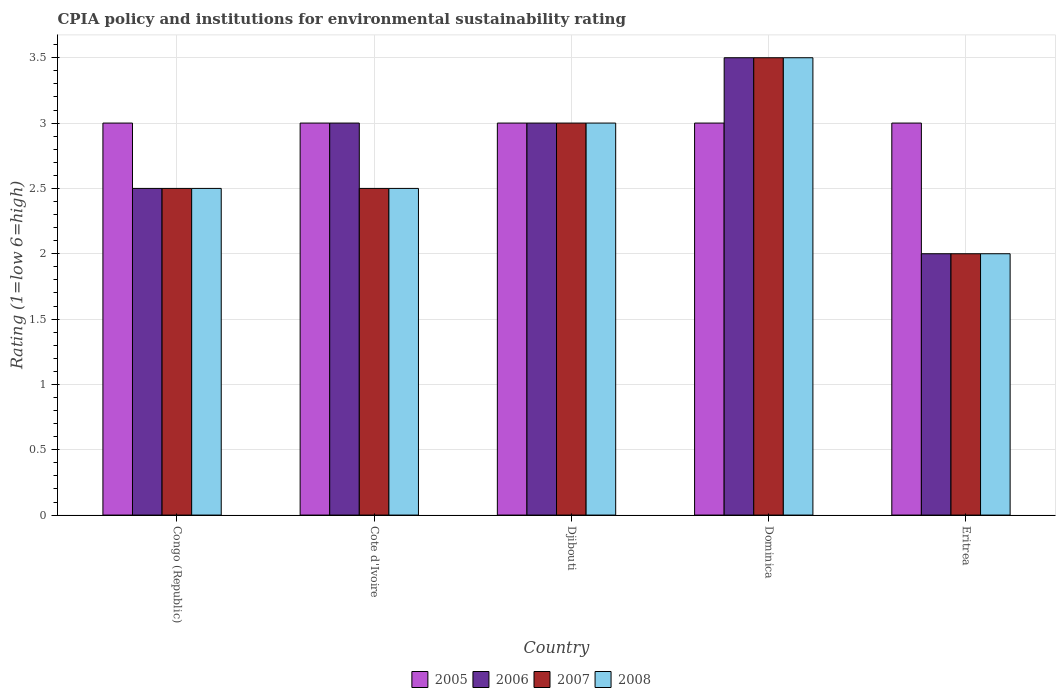Are the number of bars on each tick of the X-axis equal?
Ensure brevity in your answer.  Yes. How many bars are there on the 5th tick from the right?
Keep it short and to the point. 4. What is the label of the 3rd group of bars from the left?
Make the answer very short. Djibouti. In how many cases, is the number of bars for a given country not equal to the number of legend labels?
Provide a succinct answer. 0. Across all countries, what is the maximum CPIA rating in 2008?
Keep it short and to the point. 3.5. Across all countries, what is the minimum CPIA rating in 2008?
Give a very brief answer. 2. In which country was the CPIA rating in 2008 maximum?
Your response must be concise. Dominica. In which country was the CPIA rating in 2008 minimum?
Provide a succinct answer. Eritrea. What is the difference between the CPIA rating in 2008 in Congo (Republic) and that in Djibouti?
Your response must be concise. -0.5. What is the difference between the CPIA rating in 2006 in Eritrea and the CPIA rating in 2007 in Djibouti?
Your answer should be very brief. -1. What is the average CPIA rating in 2008 per country?
Offer a terse response. 2.7. What is the difference between the CPIA rating of/in 2008 and CPIA rating of/in 2007 in Djibouti?
Your answer should be very brief. 0. In how many countries, is the CPIA rating in 2008 greater than 1.3?
Your answer should be very brief. 5. What is the ratio of the CPIA rating in 2006 in Congo (Republic) to that in Cote d'Ivoire?
Keep it short and to the point. 0.83. Is the CPIA rating in 2005 in Congo (Republic) less than that in Djibouti?
Your answer should be very brief. No. In how many countries, is the CPIA rating in 2007 greater than the average CPIA rating in 2007 taken over all countries?
Provide a succinct answer. 2. What does the 1st bar from the left in Dominica represents?
Keep it short and to the point. 2005. How many bars are there?
Offer a very short reply. 20. Are all the bars in the graph horizontal?
Give a very brief answer. No. How many countries are there in the graph?
Your answer should be very brief. 5. Are the values on the major ticks of Y-axis written in scientific E-notation?
Offer a very short reply. No. Does the graph contain any zero values?
Offer a terse response. No. Does the graph contain grids?
Offer a terse response. Yes. Where does the legend appear in the graph?
Keep it short and to the point. Bottom center. How many legend labels are there?
Provide a short and direct response. 4. How are the legend labels stacked?
Make the answer very short. Horizontal. What is the title of the graph?
Provide a short and direct response. CPIA policy and institutions for environmental sustainability rating. What is the label or title of the Y-axis?
Provide a succinct answer. Rating (1=low 6=high). What is the Rating (1=low 6=high) of 2005 in Congo (Republic)?
Your response must be concise. 3. What is the Rating (1=low 6=high) in 2008 in Congo (Republic)?
Provide a succinct answer. 2.5. What is the Rating (1=low 6=high) in 2005 in Cote d'Ivoire?
Your answer should be very brief. 3. What is the Rating (1=low 6=high) of 2006 in Cote d'Ivoire?
Provide a succinct answer. 3. What is the Rating (1=low 6=high) in 2007 in Cote d'Ivoire?
Ensure brevity in your answer.  2.5. What is the Rating (1=low 6=high) of 2008 in Djibouti?
Offer a terse response. 3. What is the Rating (1=low 6=high) in 2005 in Dominica?
Give a very brief answer. 3. What is the Rating (1=low 6=high) of 2008 in Dominica?
Your response must be concise. 3.5. What is the Rating (1=low 6=high) of 2005 in Eritrea?
Offer a very short reply. 3. What is the Rating (1=low 6=high) of 2006 in Eritrea?
Provide a succinct answer. 2. What is the Rating (1=low 6=high) in 2008 in Eritrea?
Provide a succinct answer. 2. Across all countries, what is the maximum Rating (1=low 6=high) in 2005?
Offer a very short reply. 3. Across all countries, what is the maximum Rating (1=low 6=high) in 2007?
Provide a short and direct response. 3.5. Across all countries, what is the minimum Rating (1=low 6=high) of 2006?
Your answer should be compact. 2. Across all countries, what is the minimum Rating (1=low 6=high) of 2007?
Offer a terse response. 2. What is the total Rating (1=low 6=high) of 2006 in the graph?
Ensure brevity in your answer.  14. What is the difference between the Rating (1=low 6=high) in 2006 in Congo (Republic) and that in Cote d'Ivoire?
Offer a very short reply. -0.5. What is the difference between the Rating (1=low 6=high) in 2007 in Congo (Republic) and that in Cote d'Ivoire?
Your answer should be very brief. 0. What is the difference between the Rating (1=low 6=high) in 2006 in Congo (Republic) and that in Djibouti?
Give a very brief answer. -0.5. What is the difference between the Rating (1=low 6=high) in 2008 in Congo (Republic) and that in Djibouti?
Ensure brevity in your answer.  -0.5. What is the difference between the Rating (1=low 6=high) of 2005 in Congo (Republic) and that in Dominica?
Offer a very short reply. 0. What is the difference between the Rating (1=low 6=high) in 2008 in Congo (Republic) and that in Dominica?
Offer a very short reply. -1. What is the difference between the Rating (1=low 6=high) in 2005 in Congo (Republic) and that in Eritrea?
Make the answer very short. 0. What is the difference between the Rating (1=low 6=high) in 2006 in Congo (Republic) and that in Eritrea?
Provide a succinct answer. 0.5. What is the difference between the Rating (1=low 6=high) in 2007 in Congo (Republic) and that in Eritrea?
Provide a short and direct response. 0.5. What is the difference between the Rating (1=low 6=high) of 2007 in Cote d'Ivoire and that in Djibouti?
Make the answer very short. -0.5. What is the difference between the Rating (1=low 6=high) in 2005 in Cote d'Ivoire and that in Dominica?
Give a very brief answer. 0. What is the difference between the Rating (1=low 6=high) of 2005 in Cote d'Ivoire and that in Eritrea?
Ensure brevity in your answer.  0. What is the difference between the Rating (1=low 6=high) in 2005 in Djibouti and that in Dominica?
Your response must be concise. 0. What is the difference between the Rating (1=low 6=high) of 2008 in Djibouti and that in Dominica?
Your response must be concise. -0.5. What is the difference between the Rating (1=low 6=high) of 2005 in Djibouti and that in Eritrea?
Offer a very short reply. 0. What is the difference between the Rating (1=low 6=high) of 2007 in Djibouti and that in Eritrea?
Provide a succinct answer. 1. What is the difference between the Rating (1=low 6=high) of 2008 in Djibouti and that in Eritrea?
Ensure brevity in your answer.  1. What is the difference between the Rating (1=low 6=high) in 2005 in Dominica and that in Eritrea?
Your answer should be compact. 0. What is the difference between the Rating (1=low 6=high) of 2006 in Dominica and that in Eritrea?
Provide a succinct answer. 1.5. What is the difference between the Rating (1=low 6=high) of 2007 in Dominica and that in Eritrea?
Your answer should be compact. 1.5. What is the difference between the Rating (1=low 6=high) of 2005 in Congo (Republic) and the Rating (1=low 6=high) of 2007 in Cote d'Ivoire?
Give a very brief answer. 0.5. What is the difference between the Rating (1=low 6=high) in 2005 in Congo (Republic) and the Rating (1=low 6=high) in 2008 in Cote d'Ivoire?
Make the answer very short. 0.5. What is the difference between the Rating (1=low 6=high) of 2006 in Congo (Republic) and the Rating (1=low 6=high) of 2007 in Cote d'Ivoire?
Make the answer very short. 0. What is the difference between the Rating (1=low 6=high) in 2006 in Congo (Republic) and the Rating (1=low 6=high) in 2008 in Cote d'Ivoire?
Keep it short and to the point. 0. What is the difference between the Rating (1=low 6=high) in 2007 in Congo (Republic) and the Rating (1=low 6=high) in 2008 in Cote d'Ivoire?
Your answer should be compact. 0. What is the difference between the Rating (1=low 6=high) of 2005 in Congo (Republic) and the Rating (1=low 6=high) of 2006 in Djibouti?
Offer a very short reply. 0. What is the difference between the Rating (1=low 6=high) in 2005 in Congo (Republic) and the Rating (1=low 6=high) in 2008 in Djibouti?
Offer a very short reply. 0. What is the difference between the Rating (1=low 6=high) of 2006 in Congo (Republic) and the Rating (1=low 6=high) of 2007 in Djibouti?
Keep it short and to the point. -0.5. What is the difference between the Rating (1=low 6=high) of 2005 in Congo (Republic) and the Rating (1=low 6=high) of 2007 in Dominica?
Give a very brief answer. -0.5. What is the difference between the Rating (1=low 6=high) in 2005 in Congo (Republic) and the Rating (1=low 6=high) in 2008 in Dominica?
Your answer should be compact. -0.5. What is the difference between the Rating (1=low 6=high) of 2006 in Congo (Republic) and the Rating (1=low 6=high) of 2008 in Dominica?
Your answer should be compact. -1. What is the difference between the Rating (1=low 6=high) in 2005 in Congo (Republic) and the Rating (1=low 6=high) in 2008 in Eritrea?
Ensure brevity in your answer.  1. What is the difference between the Rating (1=low 6=high) of 2006 in Congo (Republic) and the Rating (1=low 6=high) of 2008 in Eritrea?
Provide a short and direct response. 0.5. What is the difference between the Rating (1=low 6=high) of 2007 in Congo (Republic) and the Rating (1=low 6=high) of 2008 in Eritrea?
Offer a terse response. 0.5. What is the difference between the Rating (1=low 6=high) of 2005 in Cote d'Ivoire and the Rating (1=low 6=high) of 2008 in Djibouti?
Your response must be concise. 0. What is the difference between the Rating (1=low 6=high) in 2007 in Cote d'Ivoire and the Rating (1=low 6=high) in 2008 in Djibouti?
Ensure brevity in your answer.  -0.5. What is the difference between the Rating (1=low 6=high) in 2005 in Cote d'Ivoire and the Rating (1=low 6=high) in 2006 in Dominica?
Your answer should be compact. -0.5. What is the difference between the Rating (1=low 6=high) of 2005 in Cote d'Ivoire and the Rating (1=low 6=high) of 2007 in Dominica?
Make the answer very short. -0.5. What is the difference between the Rating (1=low 6=high) of 2005 in Cote d'Ivoire and the Rating (1=low 6=high) of 2008 in Dominica?
Give a very brief answer. -0.5. What is the difference between the Rating (1=low 6=high) of 2006 in Cote d'Ivoire and the Rating (1=low 6=high) of 2008 in Dominica?
Keep it short and to the point. -0.5. What is the difference between the Rating (1=low 6=high) of 2005 in Cote d'Ivoire and the Rating (1=low 6=high) of 2006 in Eritrea?
Ensure brevity in your answer.  1. What is the difference between the Rating (1=low 6=high) in 2005 in Cote d'Ivoire and the Rating (1=low 6=high) in 2007 in Eritrea?
Offer a very short reply. 1. What is the difference between the Rating (1=low 6=high) of 2006 in Cote d'Ivoire and the Rating (1=low 6=high) of 2007 in Eritrea?
Offer a terse response. 1. What is the difference between the Rating (1=low 6=high) in 2007 in Cote d'Ivoire and the Rating (1=low 6=high) in 2008 in Eritrea?
Provide a short and direct response. 0.5. What is the difference between the Rating (1=low 6=high) in 2005 in Djibouti and the Rating (1=low 6=high) in 2007 in Dominica?
Your answer should be compact. -0.5. What is the difference between the Rating (1=low 6=high) of 2005 in Djibouti and the Rating (1=low 6=high) of 2008 in Dominica?
Make the answer very short. -0.5. What is the difference between the Rating (1=low 6=high) in 2007 in Djibouti and the Rating (1=low 6=high) in 2008 in Dominica?
Provide a succinct answer. -0.5. What is the difference between the Rating (1=low 6=high) in 2005 in Djibouti and the Rating (1=low 6=high) in 2008 in Eritrea?
Keep it short and to the point. 1. What is the difference between the Rating (1=low 6=high) in 2006 in Djibouti and the Rating (1=low 6=high) in 2008 in Eritrea?
Your response must be concise. 1. What is the difference between the Rating (1=low 6=high) in 2005 in Dominica and the Rating (1=low 6=high) in 2007 in Eritrea?
Your response must be concise. 1. What is the difference between the Rating (1=low 6=high) of 2006 in Dominica and the Rating (1=low 6=high) of 2007 in Eritrea?
Offer a very short reply. 1.5. What is the average Rating (1=low 6=high) in 2008 per country?
Your response must be concise. 2.7. What is the difference between the Rating (1=low 6=high) in 2005 and Rating (1=low 6=high) in 2006 in Congo (Republic)?
Your response must be concise. 0.5. What is the difference between the Rating (1=low 6=high) in 2007 and Rating (1=low 6=high) in 2008 in Congo (Republic)?
Provide a succinct answer. 0. What is the difference between the Rating (1=low 6=high) in 2005 and Rating (1=low 6=high) in 2006 in Cote d'Ivoire?
Your answer should be very brief. 0. What is the difference between the Rating (1=low 6=high) of 2005 and Rating (1=low 6=high) of 2008 in Cote d'Ivoire?
Your answer should be very brief. 0.5. What is the difference between the Rating (1=low 6=high) of 2006 and Rating (1=low 6=high) of 2007 in Cote d'Ivoire?
Offer a very short reply. 0.5. What is the difference between the Rating (1=low 6=high) in 2006 and Rating (1=low 6=high) in 2008 in Cote d'Ivoire?
Keep it short and to the point. 0.5. What is the difference between the Rating (1=low 6=high) in 2007 and Rating (1=low 6=high) in 2008 in Cote d'Ivoire?
Keep it short and to the point. 0. What is the difference between the Rating (1=low 6=high) of 2005 and Rating (1=low 6=high) of 2006 in Djibouti?
Keep it short and to the point. 0. What is the difference between the Rating (1=low 6=high) in 2005 and Rating (1=low 6=high) in 2007 in Djibouti?
Keep it short and to the point. 0. What is the difference between the Rating (1=low 6=high) in 2006 and Rating (1=low 6=high) in 2007 in Djibouti?
Your answer should be compact. 0. What is the difference between the Rating (1=low 6=high) of 2007 and Rating (1=low 6=high) of 2008 in Djibouti?
Your answer should be very brief. 0. What is the difference between the Rating (1=low 6=high) of 2005 and Rating (1=low 6=high) of 2006 in Dominica?
Keep it short and to the point. -0.5. What is the difference between the Rating (1=low 6=high) in 2005 and Rating (1=low 6=high) in 2007 in Dominica?
Provide a succinct answer. -0.5. What is the difference between the Rating (1=low 6=high) of 2005 and Rating (1=low 6=high) of 2008 in Dominica?
Offer a very short reply. -0.5. What is the difference between the Rating (1=low 6=high) of 2006 and Rating (1=low 6=high) of 2007 in Dominica?
Provide a short and direct response. 0. What is the difference between the Rating (1=low 6=high) of 2006 and Rating (1=low 6=high) of 2008 in Dominica?
Give a very brief answer. 0. What is the difference between the Rating (1=low 6=high) in 2007 and Rating (1=low 6=high) in 2008 in Dominica?
Give a very brief answer. 0. What is the difference between the Rating (1=low 6=high) of 2005 and Rating (1=low 6=high) of 2008 in Eritrea?
Your response must be concise. 1. What is the difference between the Rating (1=low 6=high) of 2007 and Rating (1=low 6=high) of 2008 in Eritrea?
Your answer should be very brief. 0. What is the ratio of the Rating (1=low 6=high) in 2005 in Congo (Republic) to that in Cote d'Ivoire?
Provide a succinct answer. 1. What is the ratio of the Rating (1=low 6=high) in 2006 in Congo (Republic) to that in Cote d'Ivoire?
Make the answer very short. 0.83. What is the ratio of the Rating (1=low 6=high) of 2007 in Congo (Republic) to that in Cote d'Ivoire?
Ensure brevity in your answer.  1. What is the ratio of the Rating (1=low 6=high) in 2008 in Congo (Republic) to that in Cote d'Ivoire?
Your answer should be compact. 1. What is the ratio of the Rating (1=low 6=high) in 2005 in Congo (Republic) to that in Djibouti?
Make the answer very short. 1. What is the ratio of the Rating (1=low 6=high) in 2007 in Congo (Republic) to that in Djibouti?
Give a very brief answer. 0.83. What is the ratio of the Rating (1=low 6=high) in 2008 in Congo (Republic) to that in Djibouti?
Provide a succinct answer. 0.83. What is the ratio of the Rating (1=low 6=high) in 2006 in Congo (Republic) to that in Dominica?
Provide a succinct answer. 0.71. What is the ratio of the Rating (1=low 6=high) of 2007 in Congo (Republic) to that in Dominica?
Keep it short and to the point. 0.71. What is the ratio of the Rating (1=low 6=high) in 2008 in Congo (Republic) to that in Dominica?
Make the answer very short. 0.71. What is the ratio of the Rating (1=low 6=high) of 2005 in Congo (Republic) to that in Eritrea?
Your answer should be very brief. 1. What is the ratio of the Rating (1=low 6=high) in 2006 in Congo (Republic) to that in Eritrea?
Offer a very short reply. 1.25. What is the ratio of the Rating (1=low 6=high) in 2007 in Congo (Republic) to that in Eritrea?
Your response must be concise. 1.25. What is the ratio of the Rating (1=low 6=high) in 2007 in Cote d'Ivoire to that in Djibouti?
Provide a short and direct response. 0.83. What is the ratio of the Rating (1=low 6=high) in 2008 in Cote d'Ivoire to that in Djibouti?
Provide a short and direct response. 0.83. What is the ratio of the Rating (1=low 6=high) in 2007 in Cote d'Ivoire to that in Dominica?
Provide a succinct answer. 0.71. What is the ratio of the Rating (1=low 6=high) of 2008 in Cote d'Ivoire to that in Dominica?
Your answer should be compact. 0.71. What is the ratio of the Rating (1=low 6=high) of 2006 in Cote d'Ivoire to that in Eritrea?
Your response must be concise. 1.5. What is the ratio of the Rating (1=low 6=high) of 2008 in Cote d'Ivoire to that in Eritrea?
Provide a succinct answer. 1.25. What is the ratio of the Rating (1=low 6=high) of 2007 in Djibouti to that in Dominica?
Keep it short and to the point. 0.86. What is the ratio of the Rating (1=low 6=high) of 2008 in Djibouti to that in Dominica?
Provide a short and direct response. 0.86. What is the ratio of the Rating (1=low 6=high) of 2006 in Djibouti to that in Eritrea?
Give a very brief answer. 1.5. What is the ratio of the Rating (1=low 6=high) of 2006 in Dominica to that in Eritrea?
Provide a short and direct response. 1.75. What is the ratio of the Rating (1=low 6=high) of 2008 in Dominica to that in Eritrea?
Give a very brief answer. 1.75. What is the difference between the highest and the second highest Rating (1=low 6=high) in 2006?
Provide a succinct answer. 0.5. What is the difference between the highest and the second highest Rating (1=low 6=high) in 2007?
Your answer should be very brief. 0.5. What is the difference between the highest and the lowest Rating (1=low 6=high) of 2006?
Offer a terse response. 1.5. What is the difference between the highest and the lowest Rating (1=low 6=high) of 2007?
Keep it short and to the point. 1.5. What is the difference between the highest and the lowest Rating (1=low 6=high) of 2008?
Offer a terse response. 1.5. 